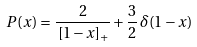<formula> <loc_0><loc_0><loc_500><loc_500>P ( x ) = \frac { 2 } { \, [ 1 - x ] _ { + } } + \frac { 3 } { 2 } \, \delta ( 1 - x )</formula> 